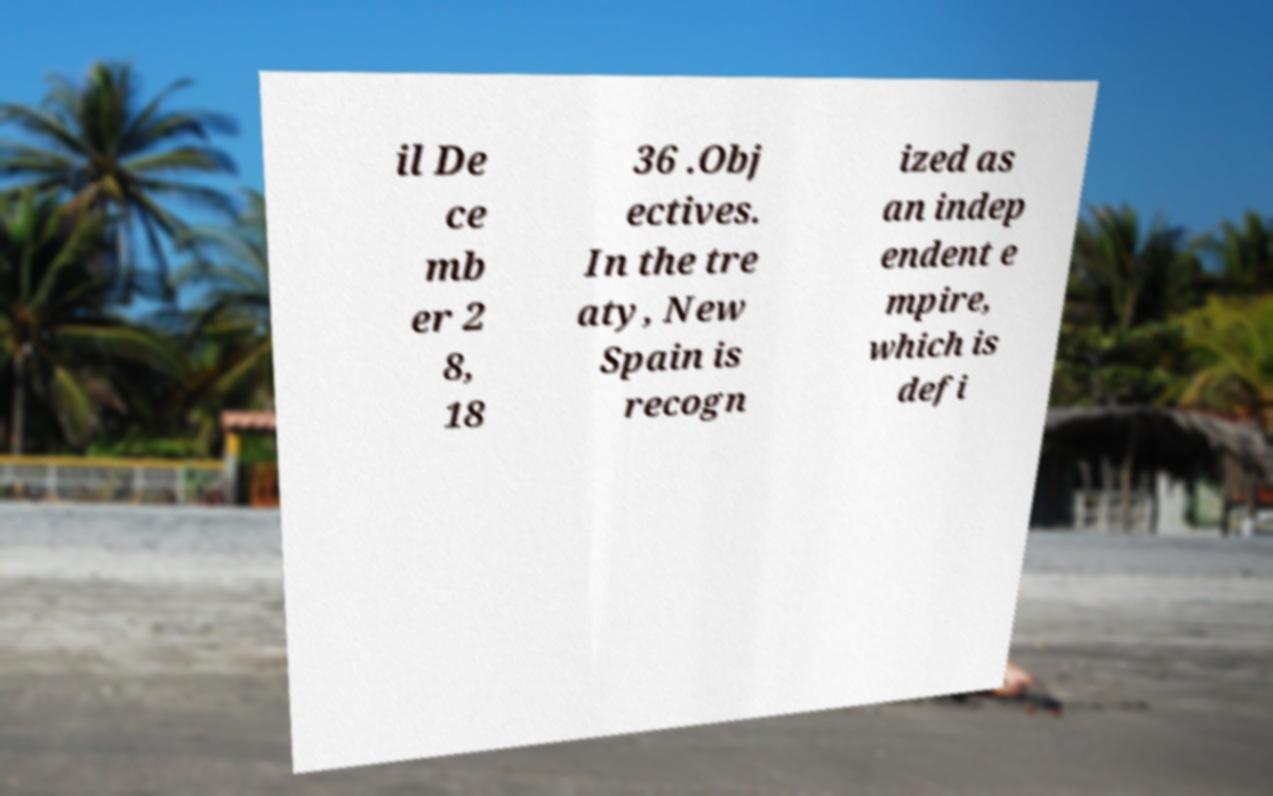I need the written content from this picture converted into text. Can you do that? il De ce mb er 2 8, 18 36 .Obj ectives. In the tre aty, New Spain is recogn ized as an indep endent e mpire, which is defi 